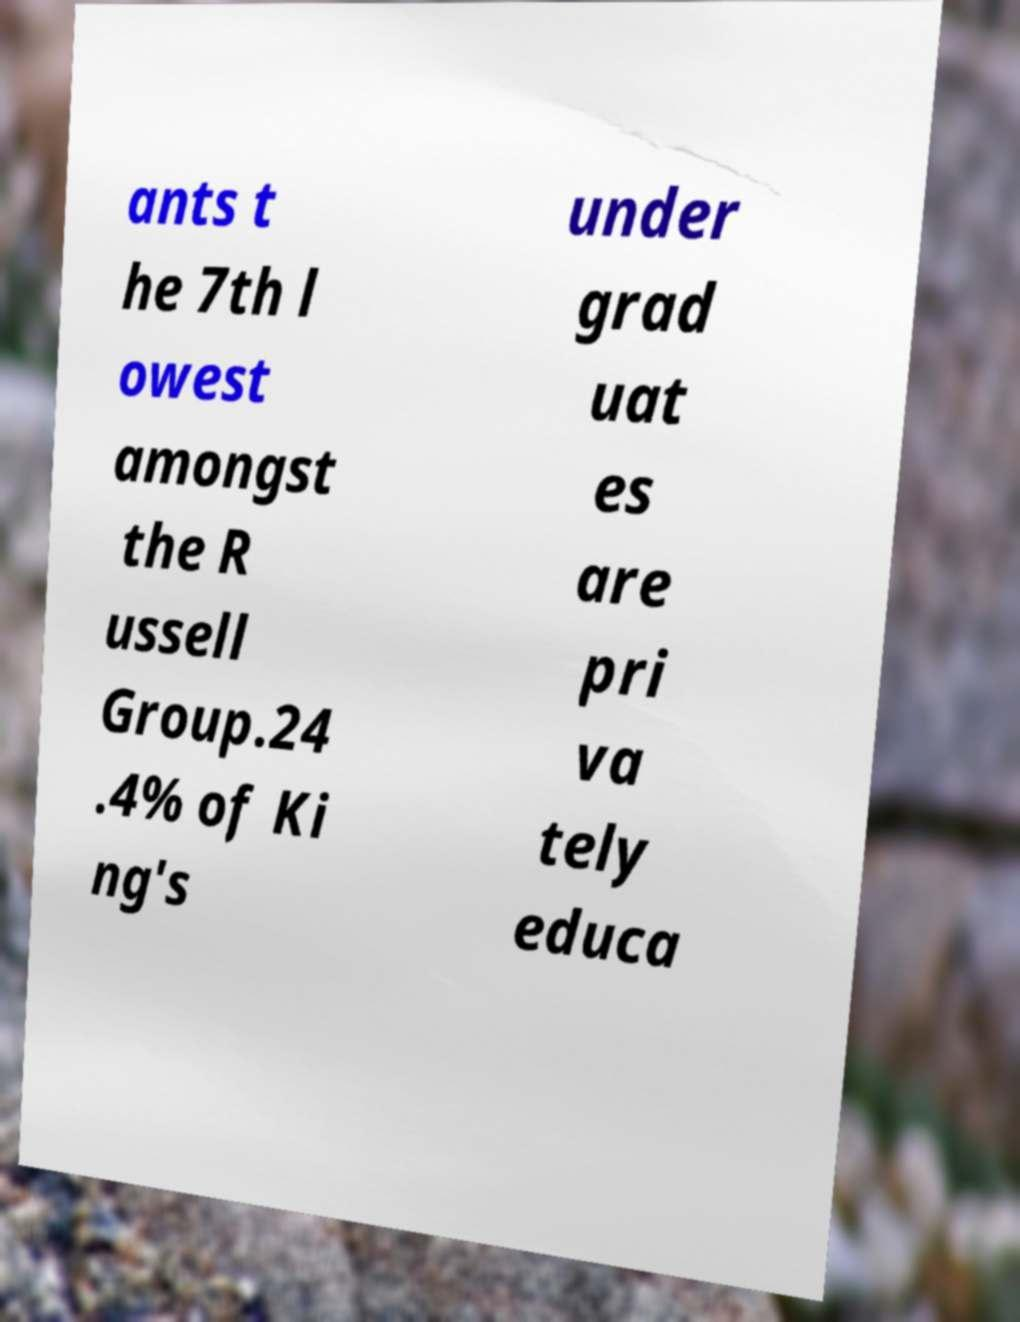Please read and relay the text visible in this image. What does it say? ants t he 7th l owest amongst the R ussell Group.24 .4% of Ki ng's under grad uat es are pri va tely educa 